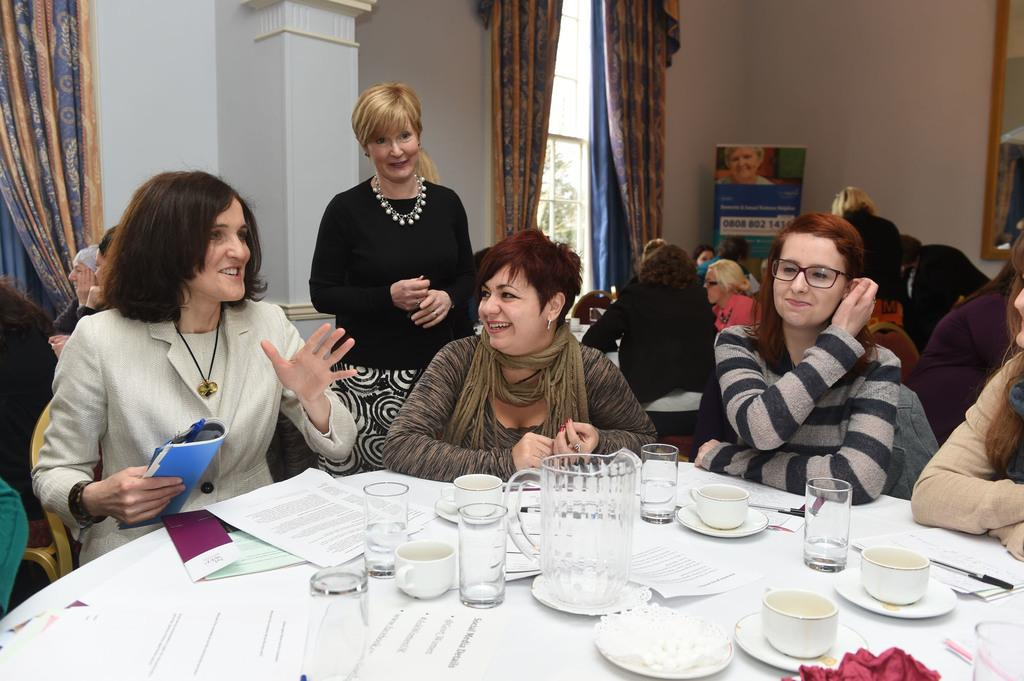What are the people in the image doing? The people in the image are sitting. What is in front of the people? There is a table in front of the people. What items can be seen on the table? There are papers, a jug, glasses, and a cup on the table. Can you see a hen jumping over the sock in the image? There is no hen or sock present in the image. 